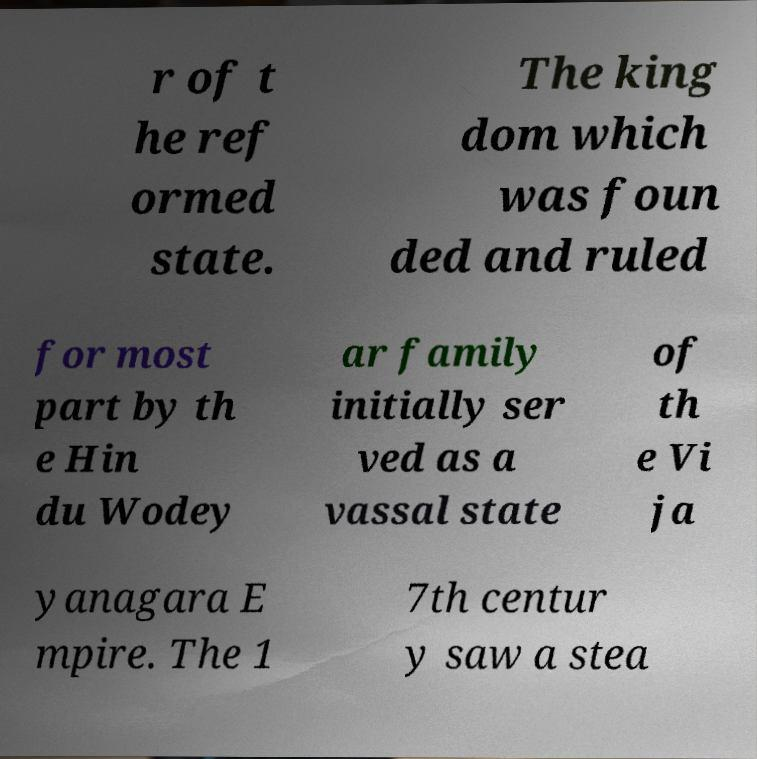There's text embedded in this image that I need extracted. Can you transcribe it verbatim? r of t he ref ormed state. The king dom which was foun ded and ruled for most part by th e Hin du Wodey ar family initially ser ved as a vassal state of th e Vi ja yanagara E mpire. The 1 7th centur y saw a stea 